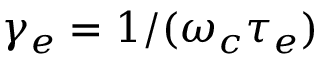<formula> <loc_0><loc_0><loc_500><loc_500>\gamma _ { e } = 1 / ( \omega _ { c } \tau _ { e } )</formula> 